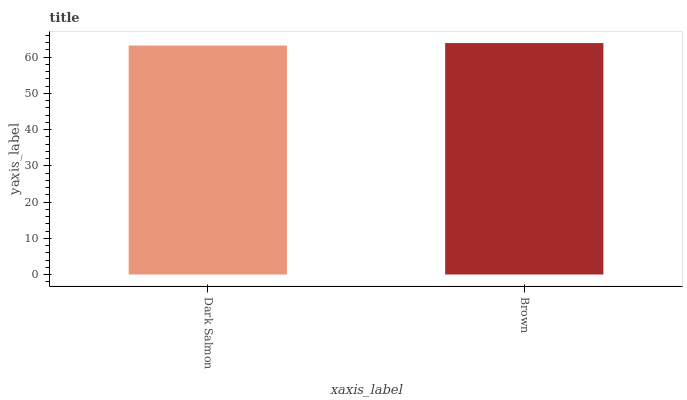Is Dark Salmon the minimum?
Answer yes or no. Yes. Is Brown the maximum?
Answer yes or no. Yes. Is Brown the minimum?
Answer yes or no. No. Is Brown greater than Dark Salmon?
Answer yes or no. Yes. Is Dark Salmon less than Brown?
Answer yes or no. Yes. Is Dark Salmon greater than Brown?
Answer yes or no. No. Is Brown less than Dark Salmon?
Answer yes or no. No. Is Brown the high median?
Answer yes or no. Yes. Is Dark Salmon the low median?
Answer yes or no. Yes. Is Dark Salmon the high median?
Answer yes or no. No. Is Brown the low median?
Answer yes or no. No. 